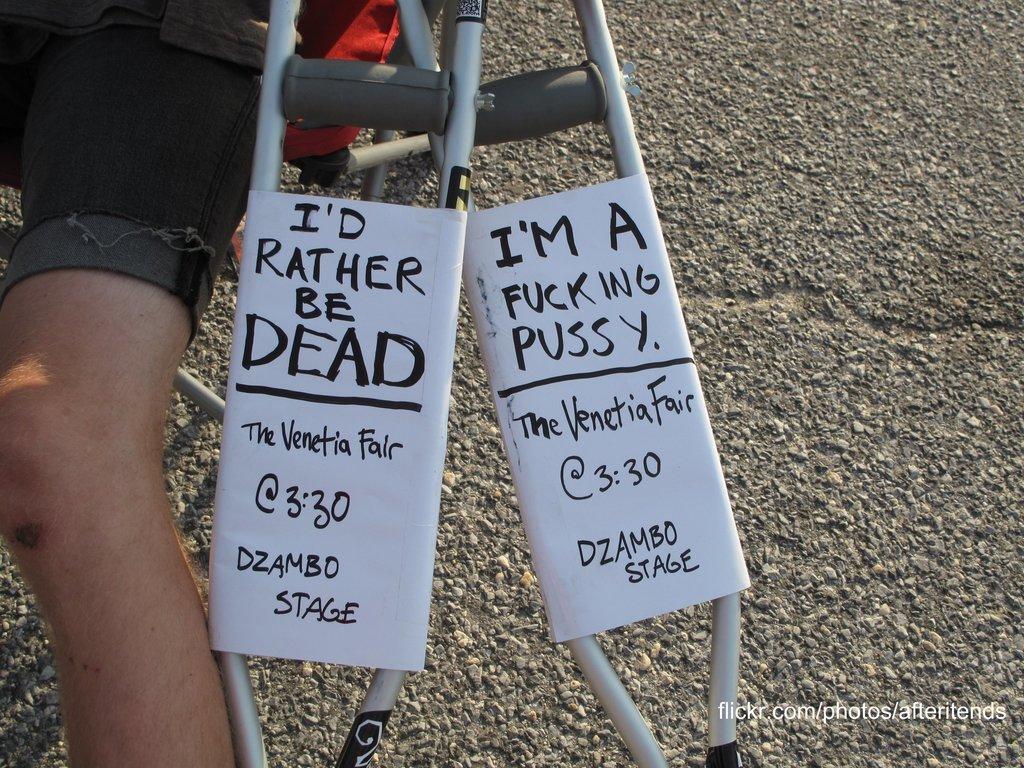How would you summarize this image in a sentence or two? On the left side of this image I can see a person's leg. Beside this person there are two walking sticks. On the right side there is a road and on the right bottom of the image I can see some text. 